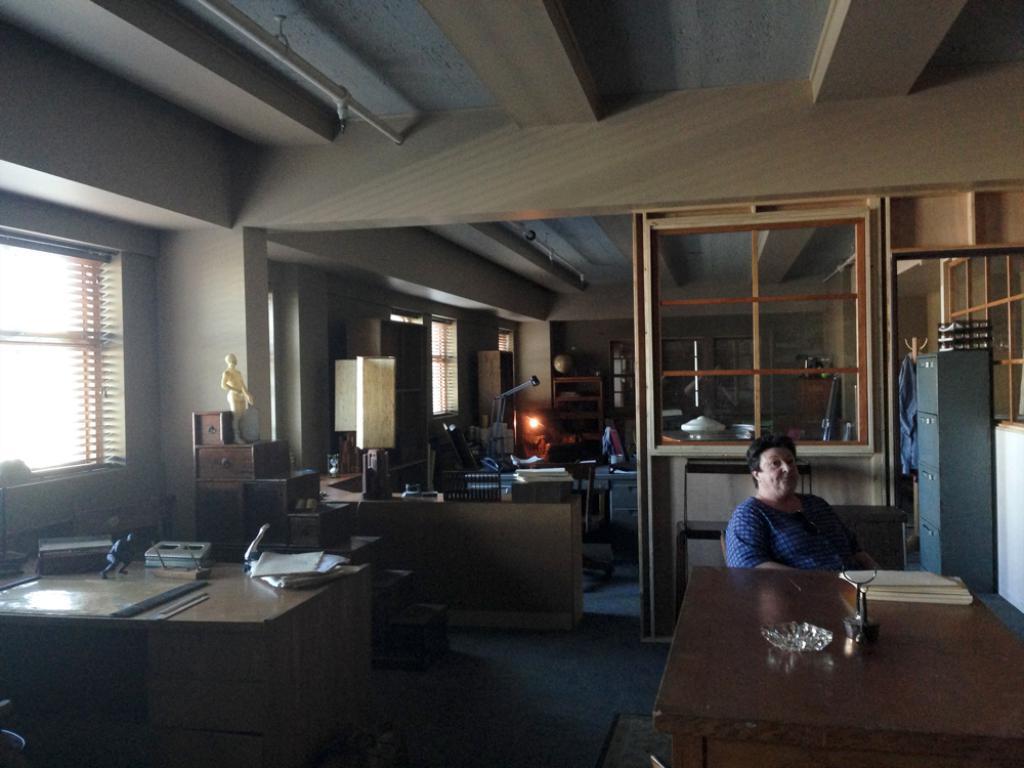In one or two sentences, can you explain what this image depicts? This image is clicked in a room where there are tables and chairs. On the tables there are plates, books, papers. There is a light in the middle. There are cupboards. There is a window blind on the left. 